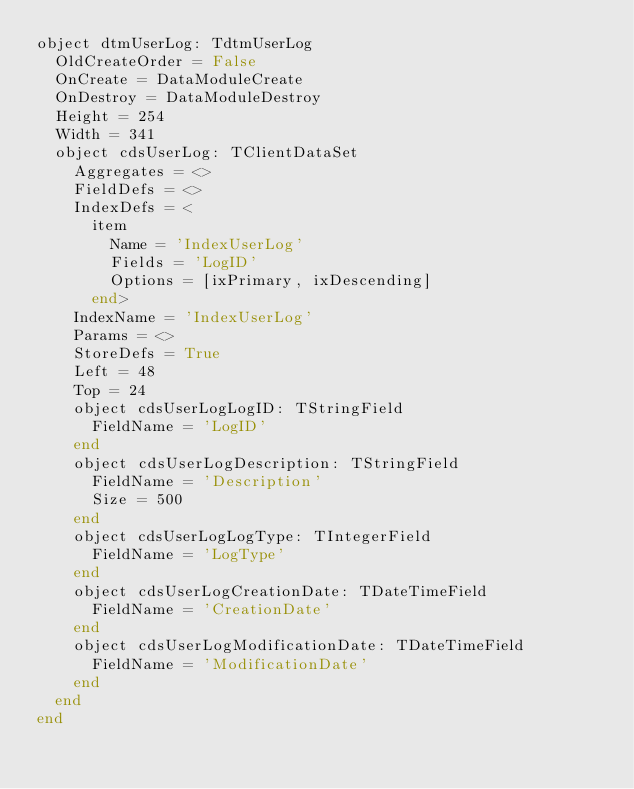<code> <loc_0><loc_0><loc_500><loc_500><_Pascal_>object dtmUserLog: TdtmUserLog
  OldCreateOrder = False
  OnCreate = DataModuleCreate
  OnDestroy = DataModuleDestroy
  Height = 254
  Width = 341
  object cdsUserLog: TClientDataSet
    Aggregates = <>
    FieldDefs = <>
    IndexDefs = <
      item
        Name = 'IndexUserLog'
        Fields = 'LogID'
        Options = [ixPrimary, ixDescending]
      end>
    IndexName = 'IndexUserLog'
    Params = <>
    StoreDefs = True
    Left = 48
    Top = 24
    object cdsUserLogLogID: TStringField
      FieldName = 'LogID'
    end
    object cdsUserLogDescription: TStringField
      FieldName = 'Description'
      Size = 500
    end
    object cdsUserLogLogType: TIntegerField
      FieldName = 'LogType'
    end
    object cdsUserLogCreationDate: TDateTimeField
      FieldName = 'CreationDate'
    end
    object cdsUserLogModificationDate: TDateTimeField
      FieldName = 'ModificationDate'
    end
  end
end
</code> 